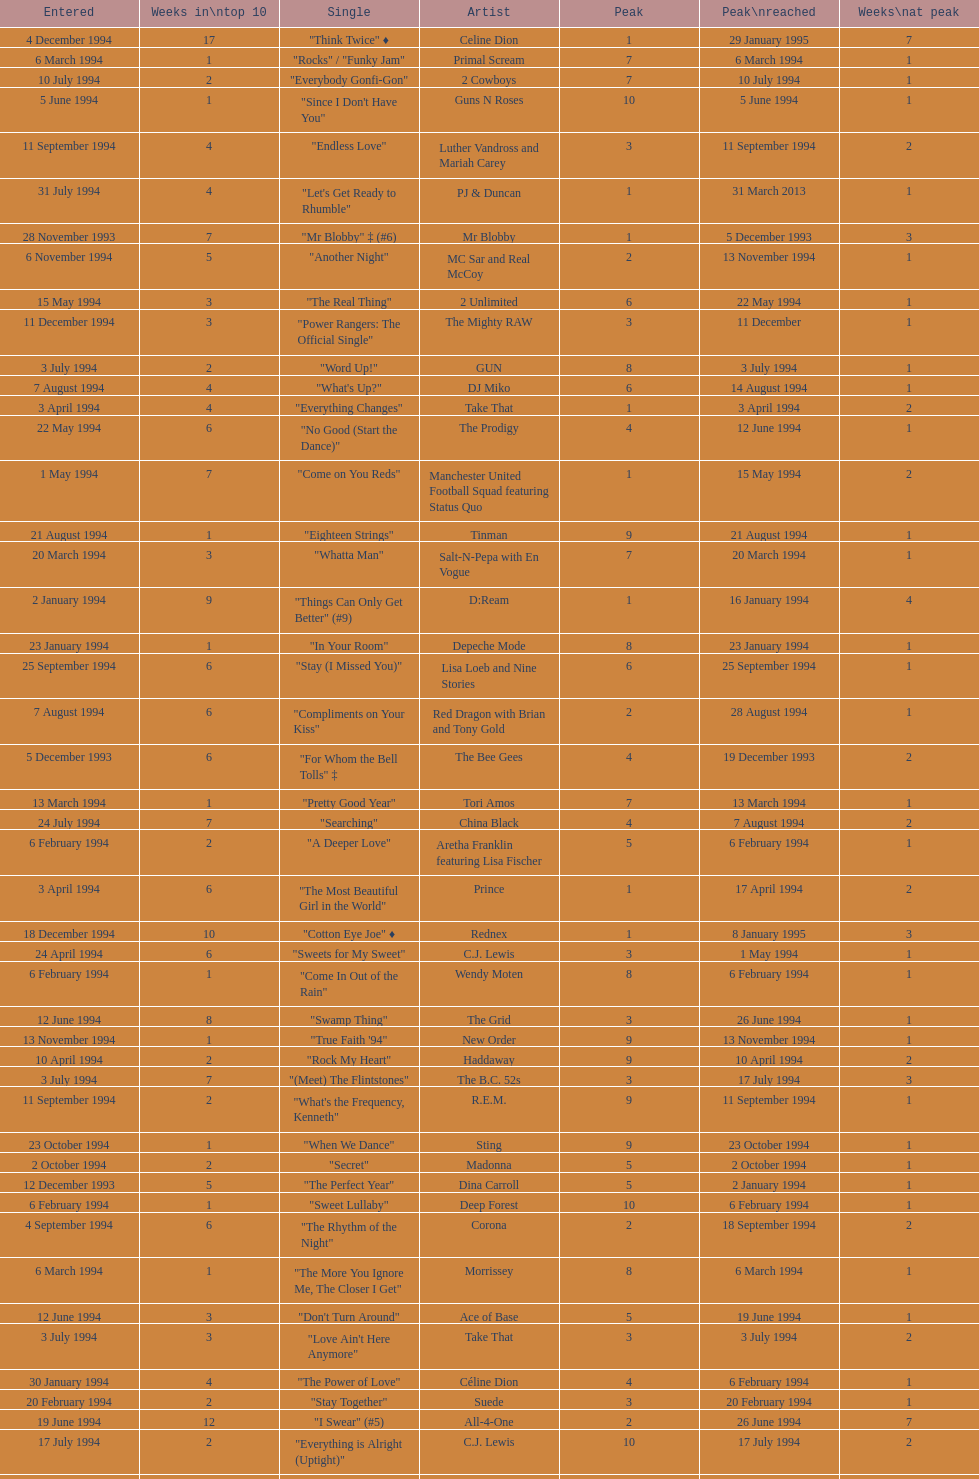Which single was the last one to be on the charts in 1993? "Come Baby Come". 